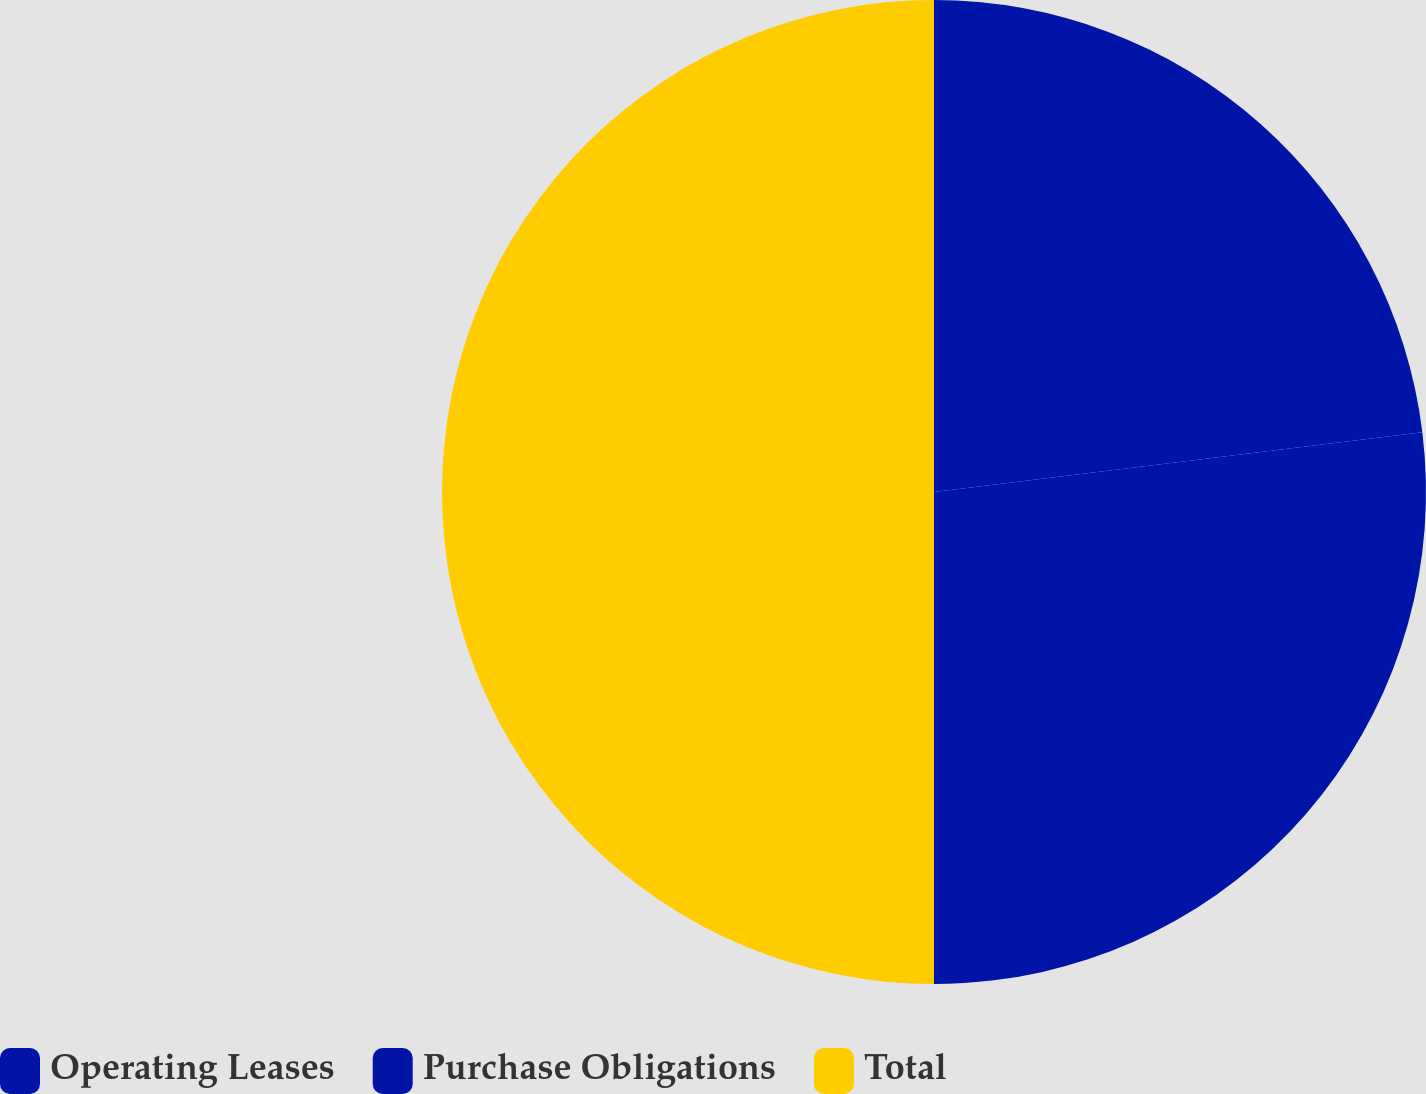Convert chart. <chart><loc_0><loc_0><loc_500><loc_500><pie_chart><fcel>Operating Leases<fcel>Purchase Obligations<fcel>Total<nl><fcel>23.06%<fcel>26.94%<fcel>50.0%<nl></chart> 